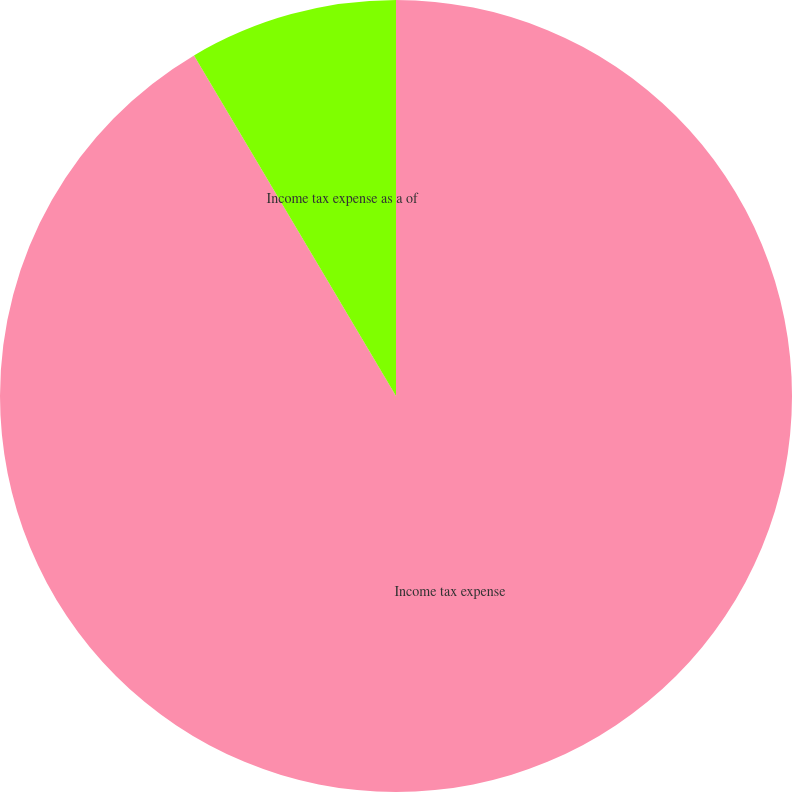Convert chart to OTSL. <chart><loc_0><loc_0><loc_500><loc_500><pie_chart><fcel>Income tax expense<fcel>Income tax expense as a of<nl><fcel>91.48%<fcel>8.52%<nl></chart> 